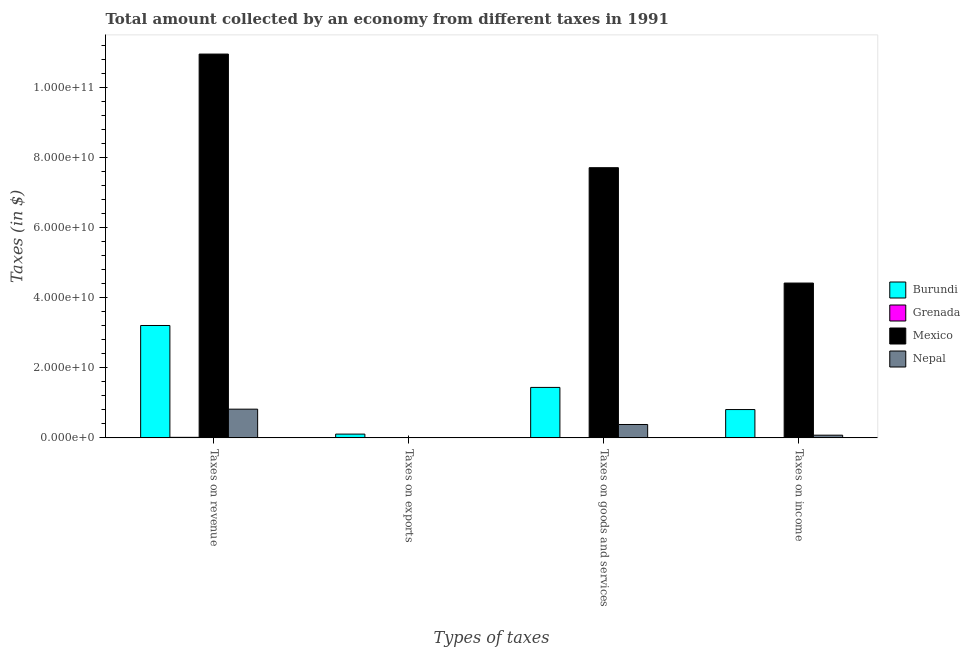Are the number of bars per tick equal to the number of legend labels?
Your response must be concise. Yes. Are the number of bars on each tick of the X-axis equal?
Provide a short and direct response. Yes. What is the label of the 1st group of bars from the left?
Provide a succinct answer. Taxes on revenue. What is the amount collected as tax on goods in Nepal?
Give a very brief answer. 3.82e+09. Across all countries, what is the maximum amount collected as tax on income?
Provide a short and direct response. 4.42e+1. Across all countries, what is the minimum amount collected as tax on income?
Offer a terse response. 2.73e+07. In which country was the amount collected as tax on income maximum?
Your answer should be compact. Mexico. In which country was the amount collected as tax on revenue minimum?
Ensure brevity in your answer.  Grenada. What is the total amount collected as tax on exports in the graph?
Offer a terse response. 1.19e+09. What is the difference between the amount collected as tax on goods in Burundi and that in Grenada?
Your answer should be compact. 1.43e+1. What is the difference between the amount collected as tax on income in Nepal and the amount collected as tax on revenue in Burundi?
Give a very brief answer. -3.13e+1. What is the average amount collected as tax on exports per country?
Keep it short and to the point. 2.98e+08. What is the difference between the amount collected as tax on revenue and amount collected as tax on income in Nepal?
Your response must be concise. 7.43e+09. What is the ratio of the amount collected as tax on goods in Nepal to that in Mexico?
Provide a succinct answer. 0.05. What is the difference between the highest and the second highest amount collected as tax on goods?
Provide a short and direct response. 6.27e+1. What is the difference between the highest and the lowest amount collected as tax on revenue?
Ensure brevity in your answer.  1.09e+11. In how many countries, is the amount collected as tax on income greater than the average amount collected as tax on income taken over all countries?
Keep it short and to the point. 1. Is it the case that in every country, the sum of the amount collected as tax on revenue and amount collected as tax on income is greater than the sum of amount collected as tax on goods and amount collected as tax on exports?
Keep it short and to the point. Yes. What does the 4th bar from the left in Taxes on income represents?
Give a very brief answer. Nepal. What does the 4th bar from the right in Taxes on revenue represents?
Your answer should be compact. Burundi. Is it the case that in every country, the sum of the amount collected as tax on revenue and amount collected as tax on exports is greater than the amount collected as tax on goods?
Provide a succinct answer. Yes. Are all the bars in the graph horizontal?
Offer a terse response. No. What is the difference between two consecutive major ticks on the Y-axis?
Keep it short and to the point. 2.00e+1. Does the graph contain any zero values?
Offer a terse response. No. Does the graph contain grids?
Your response must be concise. No. Where does the legend appear in the graph?
Provide a short and direct response. Center right. How many legend labels are there?
Keep it short and to the point. 4. How are the legend labels stacked?
Provide a succinct answer. Vertical. What is the title of the graph?
Your answer should be very brief. Total amount collected by an economy from different taxes in 1991. Does "Netherlands" appear as one of the legend labels in the graph?
Keep it short and to the point. No. What is the label or title of the X-axis?
Offer a very short reply. Types of taxes. What is the label or title of the Y-axis?
Provide a short and direct response. Taxes (in $). What is the Taxes (in $) of Burundi in Taxes on revenue?
Keep it short and to the point. 3.21e+1. What is the Taxes (in $) of Grenada in Taxes on revenue?
Your answer should be compact. 1.50e+08. What is the Taxes (in $) of Mexico in Taxes on revenue?
Keep it short and to the point. 1.10e+11. What is the Taxes (in $) in Nepal in Taxes on revenue?
Your answer should be compact. 8.20e+09. What is the Taxes (in $) of Burundi in Taxes on exports?
Keep it short and to the point. 1.07e+09. What is the Taxes (in $) in Grenada in Taxes on exports?
Give a very brief answer. 10000. What is the Taxes (in $) in Mexico in Taxes on exports?
Ensure brevity in your answer.  4.10e+07. What is the Taxes (in $) of Nepal in Taxes on exports?
Make the answer very short. 7.80e+07. What is the Taxes (in $) in Burundi in Taxes on goods and services?
Offer a terse response. 1.44e+1. What is the Taxes (in $) of Grenada in Taxes on goods and services?
Offer a very short reply. 7.61e+07. What is the Taxes (in $) in Mexico in Taxes on goods and services?
Offer a terse response. 7.71e+1. What is the Taxes (in $) in Nepal in Taxes on goods and services?
Offer a terse response. 3.82e+09. What is the Taxes (in $) of Burundi in Taxes on income?
Make the answer very short. 8.08e+09. What is the Taxes (in $) in Grenada in Taxes on income?
Provide a succinct answer. 2.73e+07. What is the Taxes (in $) of Mexico in Taxes on income?
Ensure brevity in your answer.  4.42e+1. What is the Taxes (in $) of Nepal in Taxes on income?
Your answer should be compact. 7.68e+08. Across all Types of taxes, what is the maximum Taxes (in $) of Burundi?
Make the answer very short. 3.21e+1. Across all Types of taxes, what is the maximum Taxes (in $) in Grenada?
Make the answer very short. 1.50e+08. Across all Types of taxes, what is the maximum Taxes (in $) in Mexico?
Offer a terse response. 1.10e+11. Across all Types of taxes, what is the maximum Taxes (in $) of Nepal?
Offer a terse response. 8.20e+09. Across all Types of taxes, what is the minimum Taxes (in $) in Burundi?
Give a very brief answer. 1.07e+09. Across all Types of taxes, what is the minimum Taxes (in $) in Mexico?
Offer a very short reply. 4.10e+07. Across all Types of taxes, what is the minimum Taxes (in $) in Nepal?
Your answer should be very brief. 7.80e+07. What is the total Taxes (in $) in Burundi in the graph?
Keep it short and to the point. 5.57e+1. What is the total Taxes (in $) of Grenada in the graph?
Your answer should be compact. 2.54e+08. What is the total Taxes (in $) in Mexico in the graph?
Your answer should be very brief. 2.31e+11. What is the total Taxes (in $) of Nepal in the graph?
Your answer should be compact. 1.29e+1. What is the difference between the Taxes (in $) of Burundi in Taxes on revenue and that in Taxes on exports?
Keep it short and to the point. 3.10e+1. What is the difference between the Taxes (in $) of Grenada in Taxes on revenue and that in Taxes on exports?
Give a very brief answer. 1.50e+08. What is the difference between the Taxes (in $) of Mexico in Taxes on revenue and that in Taxes on exports?
Offer a very short reply. 1.10e+11. What is the difference between the Taxes (in $) in Nepal in Taxes on revenue and that in Taxes on exports?
Keep it short and to the point. 8.12e+09. What is the difference between the Taxes (in $) in Burundi in Taxes on revenue and that in Taxes on goods and services?
Make the answer very short. 1.77e+1. What is the difference between the Taxes (in $) in Grenada in Taxes on revenue and that in Taxes on goods and services?
Ensure brevity in your answer.  7.42e+07. What is the difference between the Taxes (in $) in Mexico in Taxes on revenue and that in Taxes on goods and services?
Make the answer very short. 3.24e+1. What is the difference between the Taxes (in $) in Nepal in Taxes on revenue and that in Taxes on goods and services?
Give a very brief answer. 4.38e+09. What is the difference between the Taxes (in $) in Burundi in Taxes on revenue and that in Taxes on income?
Ensure brevity in your answer.  2.40e+1. What is the difference between the Taxes (in $) in Grenada in Taxes on revenue and that in Taxes on income?
Offer a terse response. 1.23e+08. What is the difference between the Taxes (in $) in Mexico in Taxes on revenue and that in Taxes on income?
Ensure brevity in your answer.  6.54e+1. What is the difference between the Taxes (in $) of Nepal in Taxes on revenue and that in Taxes on income?
Provide a succinct answer. 7.43e+09. What is the difference between the Taxes (in $) of Burundi in Taxes on exports and that in Taxes on goods and services?
Keep it short and to the point. -1.33e+1. What is the difference between the Taxes (in $) in Grenada in Taxes on exports and that in Taxes on goods and services?
Offer a very short reply. -7.61e+07. What is the difference between the Taxes (in $) of Mexico in Taxes on exports and that in Taxes on goods and services?
Offer a terse response. -7.71e+1. What is the difference between the Taxes (in $) in Nepal in Taxes on exports and that in Taxes on goods and services?
Your response must be concise. -3.74e+09. What is the difference between the Taxes (in $) of Burundi in Taxes on exports and that in Taxes on income?
Make the answer very short. -7.01e+09. What is the difference between the Taxes (in $) in Grenada in Taxes on exports and that in Taxes on income?
Give a very brief answer. -2.73e+07. What is the difference between the Taxes (in $) in Mexico in Taxes on exports and that in Taxes on income?
Give a very brief answer. -4.42e+1. What is the difference between the Taxes (in $) of Nepal in Taxes on exports and that in Taxes on income?
Make the answer very short. -6.90e+08. What is the difference between the Taxes (in $) of Burundi in Taxes on goods and services and that in Taxes on income?
Give a very brief answer. 6.32e+09. What is the difference between the Taxes (in $) in Grenada in Taxes on goods and services and that in Taxes on income?
Offer a very short reply. 4.88e+07. What is the difference between the Taxes (in $) in Mexico in Taxes on goods and services and that in Taxes on income?
Make the answer very short. 3.29e+1. What is the difference between the Taxes (in $) in Nepal in Taxes on goods and services and that in Taxes on income?
Make the answer very short. 3.05e+09. What is the difference between the Taxes (in $) of Burundi in Taxes on revenue and the Taxes (in $) of Grenada in Taxes on exports?
Your answer should be very brief. 3.21e+1. What is the difference between the Taxes (in $) in Burundi in Taxes on revenue and the Taxes (in $) in Mexico in Taxes on exports?
Your answer should be very brief. 3.20e+1. What is the difference between the Taxes (in $) of Burundi in Taxes on revenue and the Taxes (in $) of Nepal in Taxes on exports?
Your response must be concise. 3.20e+1. What is the difference between the Taxes (in $) of Grenada in Taxes on revenue and the Taxes (in $) of Mexico in Taxes on exports?
Provide a succinct answer. 1.09e+08. What is the difference between the Taxes (in $) of Grenada in Taxes on revenue and the Taxes (in $) of Nepal in Taxes on exports?
Offer a terse response. 7.23e+07. What is the difference between the Taxes (in $) of Mexico in Taxes on revenue and the Taxes (in $) of Nepal in Taxes on exports?
Your response must be concise. 1.10e+11. What is the difference between the Taxes (in $) in Burundi in Taxes on revenue and the Taxes (in $) in Grenada in Taxes on goods and services?
Your response must be concise. 3.20e+1. What is the difference between the Taxes (in $) in Burundi in Taxes on revenue and the Taxes (in $) in Mexico in Taxes on goods and services?
Provide a succinct answer. -4.51e+1. What is the difference between the Taxes (in $) of Burundi in Taxes on revenue and the Taxes (in $) of Nepal in Taxes on goods and services?
Provide a short and direct response. 2.83e+1. What is the difference between the Taxes (in $) of Grenada in Taxes on revenue and the Taxes (in $) of Mexico in Taxes on goods and services?
Your answer should be compact. -7.70e+1. What is the difference between the Taxes (in $) in Grenada in Taxes on revenue and the Taxes (in $) in Nepal in Taxes on goods and services?
Provide a succinct answer. -3.67e+09. What is the difference between the Taxes (in $) in Mexico in Taxes on revenue and the Taxes (in $) in Nepal in Taxes on goods and services?
Your answer should be very brief. 1.06e+11. What is the difference between the Taxes (in $) in Burundi in Taxes on revenue and the Taxes (in $) in Grenada in Taxes on income?
Provide a short and direct response. 3.21e+1. What is the difference between the Taxes (in $) in Burundi in Taxes on revenue and the Taxes (in $) in Mexico in Taxes on income?
Provide a short and direct response. -1.21e+1. What is the difference between the Taxes (in $) in Burundi in Taxes on revenue and the Taxes (in $) in Nepal in Taxes on income?
Provide a short and direct response. 3.13e+1. What is the difference between the Taxes (in $) in Grenada in Taxes on revenue and the Taxes (in $) in Mexico in Taxes on income?
Offer a terse response. -4.41e+1. What is the difference between the Taxes (in $) in Grenada in Taxes on revenue and the Taxes (in $) in Nepal in Taxes on income?
Ensure brevity in your answer.  -6.18e+08. What is the difference between the Taxes (in $) of Mexico in Taxes on revenue and the Taxes (in $) of Nepal in Taxes on income?
Provide a succinct answer. 1.09e+11. What is the difference between the Taxes (in $) of Burundi in Taxes on exports and the Taxes (in $) of Grenada in Taxes on goods and services?
Make the answer very short. 9.98e+08. What is the difference between the Taxes (in $) of Burundi in Taxes on exports and the Taxes (in $) of Mexico in Taxes on goods and services?
Provide a succinct answer. -7.61e+1. What is the difference between the Taxes (in $) in Burundi in Taxes on exports and the Taxes (in $) in Nepal in Taxes on goods and services?
Your answer should be very brief. -2.75e+09. What is the difference between the Taxes (in $) of Grenada in Taxes on exports and the Taxes (in $) of Mexico in Taxes on goods and services?
Give a very brief answer. -7.71e+1. What is the difference between the Taxes (in $) of Grenada in Taxes on exports and the Taxes (in $) of Nepal in Taxes on goods and services?
Make the answer very short. -3.82e+09. What is the difference between the Taxes (in $) of Mexico in Taxes on exports and the Taxes (in $) of Nepal in Taxes on goods and services?
Offer a terse response. -3.78e+09. What is the difference between the Taxes (in $) in Burundi in Taxes on exports and the Taxes (in $) in Grenada in Taxes on income?
Ensure brevity in your answer.  1.05e+09. What is the difference between the Taxes (in $) in Burundi in Taxes on exports and the Taxes (in $) in Mexico in Taxes on income?
Your answer should be compact. -4.31e+1. What is the difference between the Taxes (in $) in Burundi in Taxes on exports and the Taxes (in $) in Nepal in Taxes on income?
Keep it short and to the point. 3.06e+08. What is the difference between the Taxes (in $) in Grenada in Taxes on exports and the Taxes (in $) in Mexico in Taxes on income?
Make the answer very short. -4.42e+1. What is the difference between the Taxes (in $) of Grenada in Taxes on exports and the Taxes (in $) of Nepal in Taxes on income?
Your answer should be compact. -7.68e+08. What is the difference between the Taxes (in $) of Mexico in Taxes on exports and the Taxes (in $) of Nepal in Taxes on income?
Your answer should be very brief. -7.27e+08. What is the difference between the Taxes (in $) of Burundi in Taxes on goods and services and the Taxes (in $) of Grenada in Taxes on income?
Offer a very short reply. 1.44e+1. What is the difference between the Taxes (in $) of Burundi in Taxes on goods and services and the Taxes (in $) of Mexico in Taxes on income?
Your answer should be compact. -2.98e+1. What is the difference between the Taxes (in $) of Burundi in Taxes on goods and services and the Taxes (in $) of Nepal in Taxes on income?
Give a very brief answer. 1.36e+1. What is the difference between the Taxes (in $) in Grenada in Taxes on goods and services and the Taxes (in $) in Mexico in Taxes on income?
Offer a terse response. -4.41e+1. What is the difference between the Taxes (in $) of Grenada in Taxes on goods and services and the Taxes (in $) of Nepal in Taxes on income?
Your response must be concise. -6.92e+08. What is the difference between the Taxes (in $) in Mexico in Taxes on goods and services and the Taxes (in $) in Nepal in Taxes on income?
Offer a very short reply. 7.64e+1. What is the average Taxes (in $) in Burundi per Types of taxes?
Keep it short and to the point. 1.39e+1. What is the average Taxes (in $) of Grenada per Types of taxes?
Provide a short and direct response. 6.34e+07. What is the average Taxes (in $) in Mexico per Types of taxes?
Give a very brief answer. 5.77e+1. What is the average Taxes (in $) of Nepal per Types of taxes?
Your answer should be compact. 3.22e+09. What is the difference between the Taxes (in $) of Burundi and Taxes (in $) of Grenada in Taxes on revenue?
Offer a terse response. 3.19e+1. What is the difference between the Taxes (in $) in Burundi and Taxes (in $) in Mexico in Taxes on revenue?
Provide a succinct answer. -7.75e+1. What is the difference between the Taxes (in $) of Burundi and Taxes (in $) of Nepal in Taxes on revenue?
Provide a succinct answer. 2.39e+1. What is the difference between the Taxes (in $) of Grenada and Taxes (in $) of Mexico in Taxes on revenue?
Provide a succinct answer. -1.09e+11. What is the difference between the Taxes (in $) in Grenada and Taxes (in $) in Nepal in Taxes on revenue?
Offer a terse response. -8.05e+09. What is the difference between the Taxes (in $) of Mexico and Taxes (in $) of Nepal in Taxes on revenue?
Provide a succinct answer. 1.01e+11. What is the difference between the Taxes (in $) in Burundi and Taxes (in $) in Grenada in Taxes on exports?
Provide a short and direct response. 1.07e+09. What is the difference between the Taxes (in $) in Burundi and Taxes (in $) in Mexico in Taxes on exports?
Provide a succinct answer. 1.03e+09. What is the difference between the Taxes (in $) of Burundi and Taxes (in $) of Nepal in Taxes on exports?
Offer a very short reply. 9.96e+08. What is the difference between the Taxes (in $) of Grenada and Taxes (in $) of Mexico in Taxes on exports?
Provide a short and direct response. -4.10e+07. What is the difference between the Taxes (in $) in Grenada and Taxes (in $) in Nepal in Taxes on exports?
Your response must be concise. -7.80e+07. What is the difference between the Taxes (in $) of Mexico and Taxes (in $) of Nepal in Taxes on exports?
Your answer should be very brief. -3.70e+07. What is the difference between the Taxes (in $) of Burundi and Taxes (in $) of Grenada in Taxes on goods and services?
Give a very brief answer. 1.43e+1. What is the difference between the Taxes (in $) in Burundi and Taxes (in $) in Mexico in Taxes on goods and services?
Provide a short and direct response. -6.27e+1. What is the difference between the Taxes (in $) in Burundi and Taxes (in $) in Nepal in Taxes on goods and services?
Ensure brevity in your answer.  1.06e+1. What is the difference between the Taxes (in $) of Grenada and Taxes (in $) of Mexico in Taxes on goods and services?
Make the answer very short. -7.71e+1. What is the difference between the Taxes (in $) in Grenada and Taxes (in $) in Nepal in Taxes on goods and services?
Provide a short and direct response. -3.74e+09. What is the difference between the Taxes (in $) in Mexico and Taxes (in $) in Nepal in Taxes on goods and services?
Ensure brevity in your answer.  7.33e+1. What is the difference between the Taxes (in $) of Burundi and Taxes (in $) of Grenada in Taxes on income?
Keep it short and to the point. 8.06e+09. What is the difference between the Taxes (in $) of Burundi and Taxes (in $) of Mexico in Taxes on income?
Make the answer very short. -3.61e+1. What is the difference between the Taxes (in $) in Burundi and Taxes (in $) in Nepal in Taxes on income?
Your answer should be very brief. 7.32e+09. What is the difference between the Taxes (in $) of Grenada and Taxes (in $) of Mexico in Taxes on income?
Provide a short and direct response. -4.42e+1. What is the difference between the Taxes (in $) of Grenada and Taxes (in $) of Nepal in Taxes on income?
Offer a terse response. -7.41e+08. What is the difference between the Taxes (in $) of Mexico and Taxes (in $) of Nepal in Taxes on income?
Make the answer very short. 4.34e+1. What is the ratio of the Taxes (in $) of Burundi in Taxes on revenue to that in Taxes on exports?
Offer a very short reply. 29.88. What is the ratio of the Taxes (in $) of Grenada in Taxes on revenue to that in Taxes on exports?
Your response must be concise. 1.50e+04. What is the ratio of the Taxes (in $) of Mexico in Taxes on revenue to that in Taxes on exports?
Make the answer very short. 2672.93. What is the ratio of the Taxes (in $) of Nepal in Taxes on revenue to that in Taxes on exports?
Your response must be concise. 105.08. What is the ratio of the Taxes (in $) of Burundi in Taxes on revenue to that in Taxes on goods and services?
Your answer should be compact. 2.23. What is the ratio of the Taxes (in $) of Grenada in Taxes on revenue to that in Taxes on goods and services?
Your answer should be very brief. 1.98. What is the ratio of the Taxes (in $) of Mexico in Taxes on revenue to that in Taxes on goods and services?
Give a very brief answer. 1.42. What is the ratio of the Taxes (in $) of Nepal in Taxes on revenue to that in Taxes on goods and services?
Offer a very short reply. 2.15. What is the ratio of the Taxes (in $) of Burundi in Taxes on revenue to that in Taxes on income?
Ensure brevity in your answer.  3.97. What is the ratio of the Taxes (in $) of Grenada in Taxes on revenue to that in Taxes on income?
Offer a terse response. 5.51. What is the ratio of the Taxes (in $) of Mexico in Taxes on revenue to that in Taxes on income?
Provide a succinct answer. 2.48. What is the ratio of the Taxes (in $) in Nepal in Taxes on revenue to that in Taxes on income?
Keep it short and to the point. 10.67. What is the ratio of the Taxes (in $) in Burundi in Taxes on exports to that in Taxes on goods and services?
Your response must be concise. 0.07. What is the ratio of the Taxes (in $) of Mexico in Taxes on exports to that in Taxes on goods and services?
Give a very brief answer. 0. What is the ratio of the Taxes (in $) in Nepal in Taxes on exports to that in Taxes on goods and services?
Offer a very short reply. 0.02. What is the ratio of the Taxes (in $) of Burundi in Taxes on exports to that in Taxes on income?
Offer a terse response. 0.13. What is the ratio of the Taxes (in $) of Grenada in Taxes on exports to that in Taxes on income?
Make the answer very short. 0. What is the ratio of the Taxes (in $) in Mexico in Taxes on exports to that in Taxes on income?
Ensure brevity in your answer.  0. What is the ratio of the Taxes (in $) in Nepal in Taxes on exports to that in Taxes on income?
Give a very brief answer. 0.1. What is the ratio of the Taxes (in $) in Burundi in Taxes on goods and services to that in Taxes on income?
Your response must be concise. 1.78. What is the ratio of the Taxes (in $) in Grenada in Taxes on goods and services to that in Taxes on income?
Give a very brief answer. 2.79. What is the ratio of the Taxes (in $) in Mexico in Taxes on goods and services to that in Taxes on income?
Your answer should be very brief. 1.75. What is the ratio of the Taxes (in $) in Nepal in Taxes on goods and services to that in Taxes on income?
Offer a very short reply. 4.98. What is the difference between the highest and the second highest Taxes (in $) in Burundi?
Provide a succinct answer. 1.77e+1. What is the difference between the highest and the second highest Taxes (in $) of Grenada?
Provide a short and direct response. 7.42e+07. What is the difference between the highest and the second highest Taxes (in $) in Mexico?
Keep it short and to the point. 3.24e+1. What is the difference between the highest and the second highest Taxes (in $) of Nepal?
Make the answer very short. 4.38e+09. What is the difference between the highest and the lowest Taxes (in $) of Burundi?
Give a very brief answer. 3.10e+1. What is the difference between the highest and the lowest Taxes (in $) of Grenada?
Keep it short and to the point. 1.50e+08. What is the difference between the highest and the lowest Taxes (in $) in Mexico?
Make the answer very short. 1.10e+11. What is the difference between the highest and the lowest Taxes (in $) in Nepal?
Make the answer very short. 8.12e+09. 